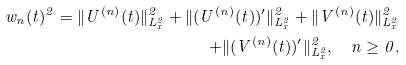<formula> <loc_0><loc_0><loc_500><loc_500>w _ { n } ( t ) ^ { 2 } = \| U ^ { ( n ) } ( t ) \| _ { L _ { x } ^ { 2 } } ^ { 2 } + \| ( U ^ { ( n ) } ( t ) ) ^ { \prime } \| _ { L _ { x } ^ { 2 } } ^ { 2 } + \| V ^ { ( n ) } ( t ) \| _ { L _ { x } ^ { 2 } } ^ { 2 } \\ + \| ( V ^ { ( n ) } ( t ) ) ^ { \prime } \| _ { L _ { x } ^ { 2 } } ^ { 2 } , \quad n \geq 0 .</formula> 